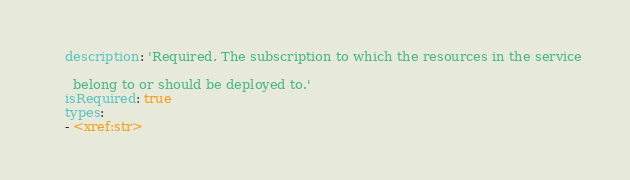Convert code to text. <code><loc_0><loc_0><loc_500><loc_500><_YAML_>    description: 'Required. The subscription to which the resources in the service

      belong to or should be deployed to.'
    isRequired: true
    types:
    - <xref:str>
</code> 